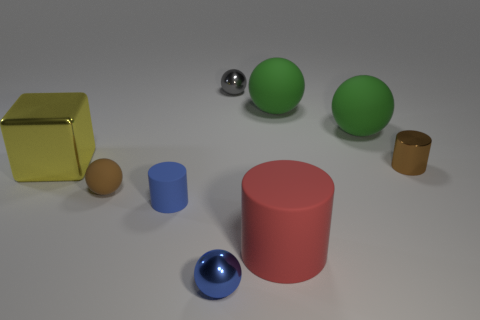What number of things are either rubber spheres or matte things that are in front of the large metallic block?
Keep it short and to the point. 5. Is the tiny ball that is behind the big shiny block made of the same material as the big red cylinder?
Give a very brief answer. No. Is there any other thing that is the same size as the metallic cube?
Your answer should be very brief. Yes. What material is the brown object that is right of the metal ball that is behind the yellow thing?
Your response must be concise. Metal. Are there more tiny brown rubber objects that are to the left of the tiny brown rubber object than large yellow shiny things that are on the right side of the large red object?
Your answer should be very brief. No. How big is the red matte thing?
Your response must be concise. Large. There is a tiny thing that is behind the yellow object; is its color the same as the tiny rubber cylinder?
Offer a very short reply. No. Is there any other thing that is the same shape as the big yellow object?
Provide a succinct answer. No. There is a tiny shiny sphere that is behind the brown metal thing; is there a brown matte thing to the right of it?
Provide a short and direct response. No. Are there fewer small metallic spheres on the left side of the block than blue cylinders that are in front of the blue rubber thing?
Give a very brief answer. No. 